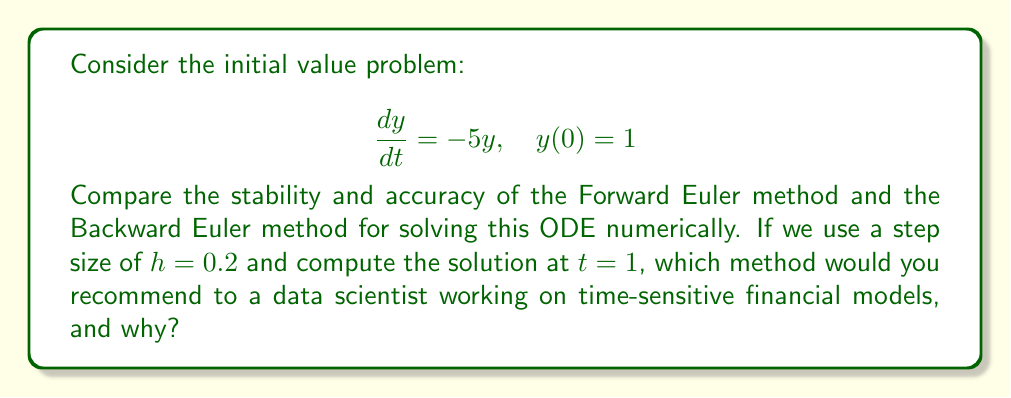What is the answer to this math problem? To evaluate the stability and accuracy of the Forward Euler and Backward Euler methods for this problem, we need to:

1. Derive the exact solution
2. Apply both numerical methods
3. Compare the results

1. Exact solution:
The exact solution to this ODE is $y(t) = e^{-5t}$. At $t = 1$, $y(1) = e^{-5} \approx 0.00673795$.

2. Numerical methods:

a) Forward Euler method:
The formula is $y_{n+1} = y_n + hf(t_n, y_n)$, where $f(t, y) = -5y$.

With $h = 0.2$ and 5 steps to reach $t = 1$:

$y_1 = 1 + 0.2(-5)(1) = 0$
$y_2 = 0 + 0.2(-5)(0) = 0$
$y_3 = y_4 = y_5 = 0$

b) Backward Euler method:
The formula is $y_{n+1} = y_n + hf(t_{n+1}, y_{n+1})$, which leads to:
$y_{n+1} = \frac{y_n}{1 + 5h}$

With $h = 0.2$ and 5 steps:

$y_1 = \frac{1}{1 + 5(0.2)} = 0.5$
$y_2 = \frac{0.5}{1 + 5(0.2)} = 0.25$
$y_3 = 0.125$
$y_4 = 0.0625$
$y_5 = 0.03125$

3. Comparison:

Stability:
- Forward Euler is unstable for this problem. It quickly drops to zero and stays there.
- Backward Euler is stable, providing a decaying solution that qualitatively matches the exact solution.

Accuracy:
- Forward Euler: Error at $t = 1$ is $|0 - 0.00673795| \approx 0.00673795$
- Backward Euler: Error at $t = 1$ is $|0.03125 - 0.00673795| \approx 0.02451205$

While Backward Euler is less accurate in this case, it maintains stability, which is crucial for many applications, especially in financial modeling where qualitative behavior is often more important than exact values.
Answer: For a data scientist working on time-sensitive financial models, the Backward Euler method would be recommended. Although it's less accurate in this specific case, it provides a stable solution that captures the qualitative behavior of the system. Stability is crucial in financial modeling to avoid spurious results that could lead to incorrect decisions. The Forward Euler method, despite being simpler, can produce unstable and unrealistic results for stiff equations often encountered in finance. 